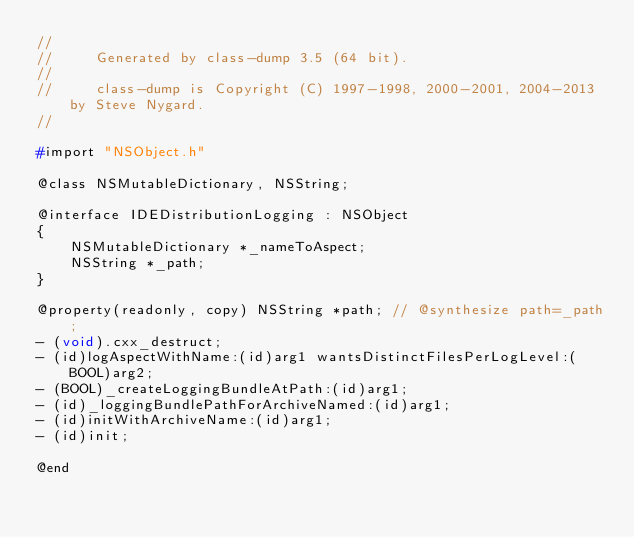<code> <loc_0><loc_0><loc_500><loc_500><_C_>//
//     Generated by class-dump 3.5 (64 bit).
//
//     class-dump is Copyright (C) 1997-1998, 2000-2001, 2004-2013 by Steve Nygard.
//

#import "NSObject.h"

@class NSMutableDictionary, NSString;

@interface IDEDistributionLogging : NSObject
{
    NSMutableDictionary *_nameToAspect;
    NSString *_path;
}

@property(readonly, copy) NSString *path; // @synthesize path=_path;
- (void).cxx_destruct;
- (id)logAspectWithName:(id)arg1 wantsDistinctFilesPerLogLevel:(BOOL)arg2;
- (BOOL)_createLoggingBundleAtPath:(id)arg1;
- (id)_loggingBundlePathForArchiveNamed:(id)arg1;
- (id)initWithArchiveName:(id)arg1;
- (id)init;

@end

</code> 